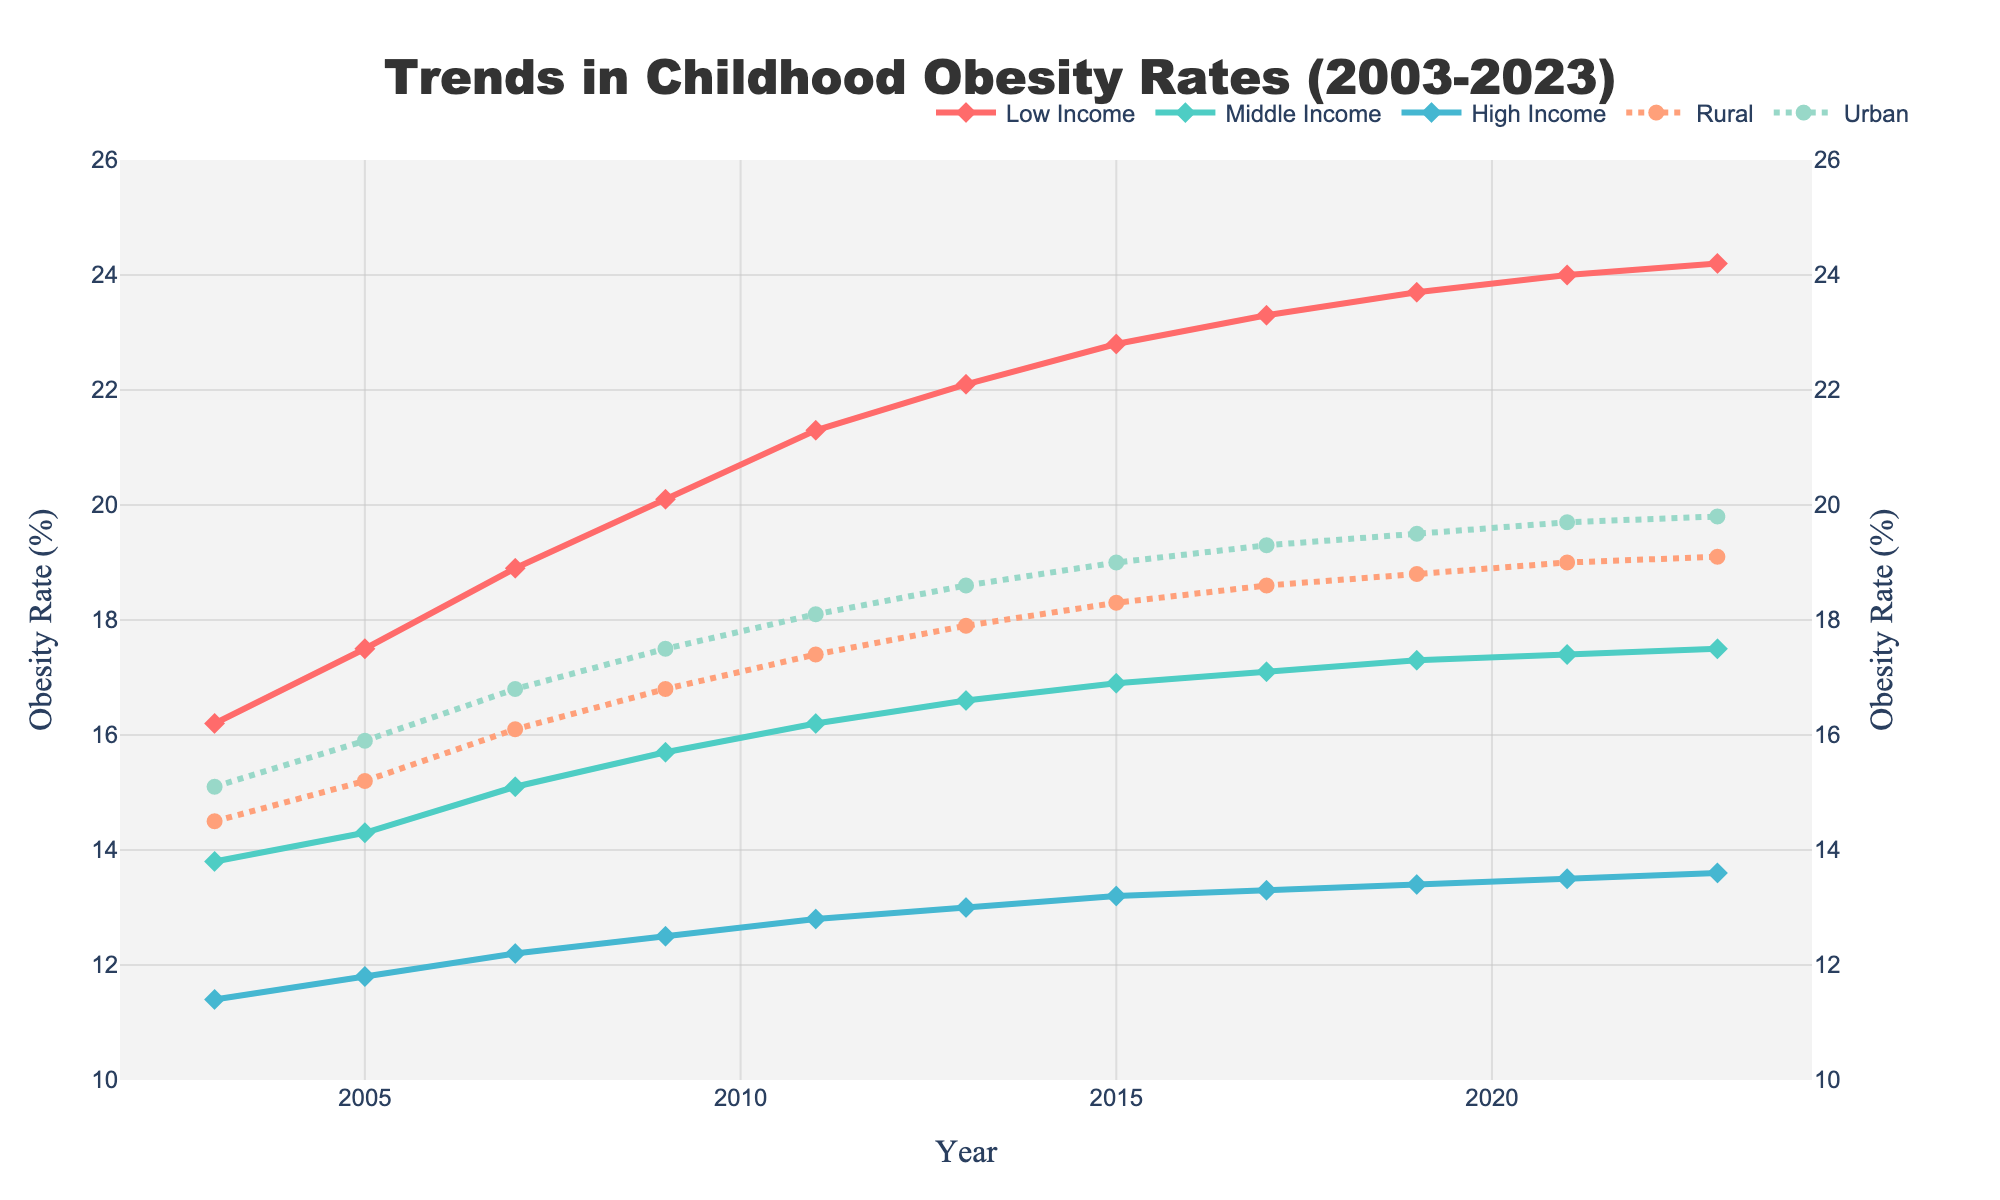How have obesity rates in the low-income group changed over the 20-year period? To answer this question, observe the trend line for the "Low Income" group from 2003 to 2023. The obesity rate increases from 16.2% in 2003 to 24.2% in 2023.
Answer: Increased from 16.2% to 24.2% Which group experienced the smallest change in obesity rates over the 20 years? This involves computing the change for each group by subtracting the 2003 value from the 2023 value and identifying the smallest difference. High Income increased by 2.2%, which is the smallest change.
Answer: High Income In 2011, which group had a higher obesity rate: Rural or Urban? Look at the 2011 point on both the "Rural" and "Urban" lines. The Rural rate was 17.4%, and the Urban rate was 18.1%.
Answer: Urban Compare the obesity trends of the Middle Income and Urban groups between 2009 and 2015. Check the values for both groups in 2009 and 2015. Middle Income increased from 15.7% to 16.9%, while Urban increased from 17.5% to 19.0%. Thus, Urban had a larger increase.
Answer: Urban increased more Which year marked the highest obesity rate for the Middle Income group? Identify the highest point on the "Middle Income" line. The peak value, 17.5%, occurred in 2023.
Answer: 2023 How did the obesity rate in the High Income group compare to the Rural group in 2009? Compare the values for 2009. High Income was at 12.5% and Rural was at 16.8%.
Answer: Rural was higher Calculate the average obesity rate for the Low Income group over the entire period. Sum up the values for Low Income and divide by the number of years. (16.2 + 17.5 + 18.9 + 20.1 + 21.3 + 22.1 + 22.8 + 23.3 + 23.7 + 24.0 + 24.2) / 11 = 20.9%.
Answer: 20.9% What is the difference between the 2023 obesity rates for the Middle Income and High Income groups? Subtract the 2023 value of High Income from Middle Income. 17.5% - 13.6% = 3.9%.
Answer: 3.9% Which socioeconomic group had a rate of increase in obesity that matched the Urban group? Determine the rate of increase for each group and match it to Urban's. Low Income and Urban both increased by around 8%.
Answer: Low Income 